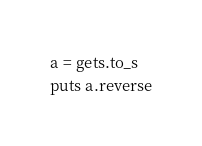<code> <loc_0><loc_0><loc_500><loc_500><_Ruby_>a = gets.to_s
puts a.reverse</code> 